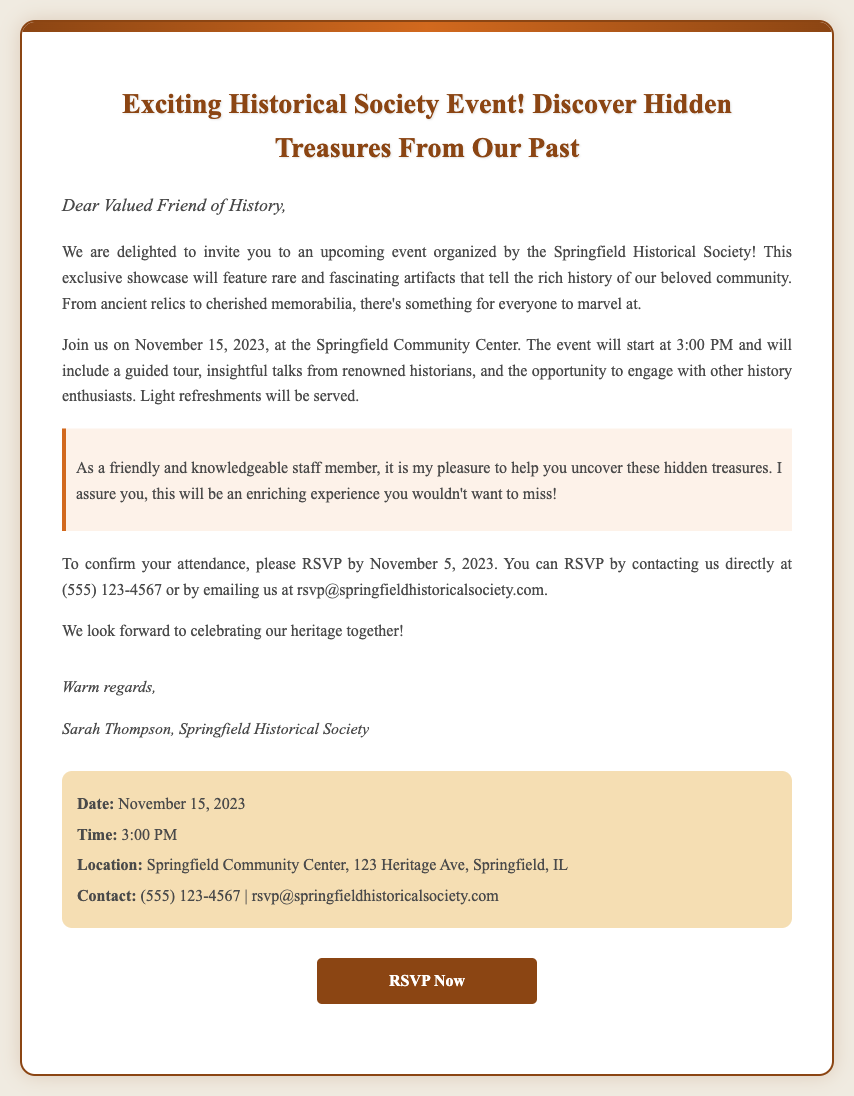What is the date of the event? The date of the event is mentioned in the document as November 15, 2023.
Answer: November 15, 2023 What is the time the event starts? The document specifies that the event will start at 3:00 PM.
Answer: 3:00 PM Where is the event taking place? The document provides the location as Springfield Community Center, specifically at 123 Heritage Ave, Springfield, IL.
Answer: Springfield Community Center, 123 Heritage Ave, Springfield, IL Who is the contact person listed for RSVPs? The document names Sarah Thompson as the contact person for the event, representing the Springfield Historical Society.
Answer: Sarah Thompson What is the RSVP deadline? The document states that the RSVP must be submitted by November 5, 2023.
Answer: November 5, 2023 What kind of activities will be included in the event? The document mentions a guided tour and insightful talks from renowned historians as part of the activities.
Answer: Guided tour and talks How can attendees RSVP for the event? The document indicates that attendees can RSVP by contacting directly at a given phone number or emailing the organization.
Answer: By phone or email What type of refreshments will be served? The document states that light refreshments will be served during the event.
Answer: Light refreshments What is the tone of the invitation? The overall tone of the invitation can be described as welcoming and enthusiastic, inviting individuals to explore history together.
Answer: Welcoming and enthusiastic 